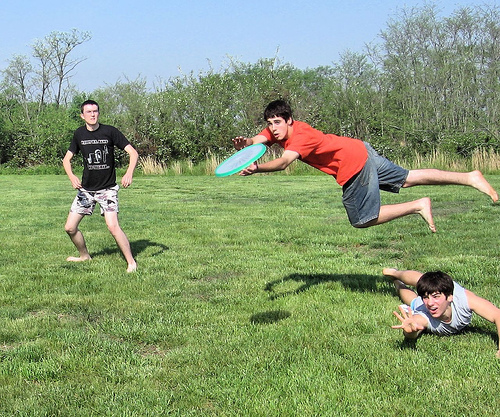What's happening in this picture? Three boys are playing frisbee in a field. One is jumping to catch the frisbee, while another is diving to the ground. The third boy is standing and watching. Describe the environment they are playing in. The boys are playing in an open grassy field with short green grass and patches of yellow. In the background, there are tall bushes and some trees. The sky is clear, indicating a sunny day. 